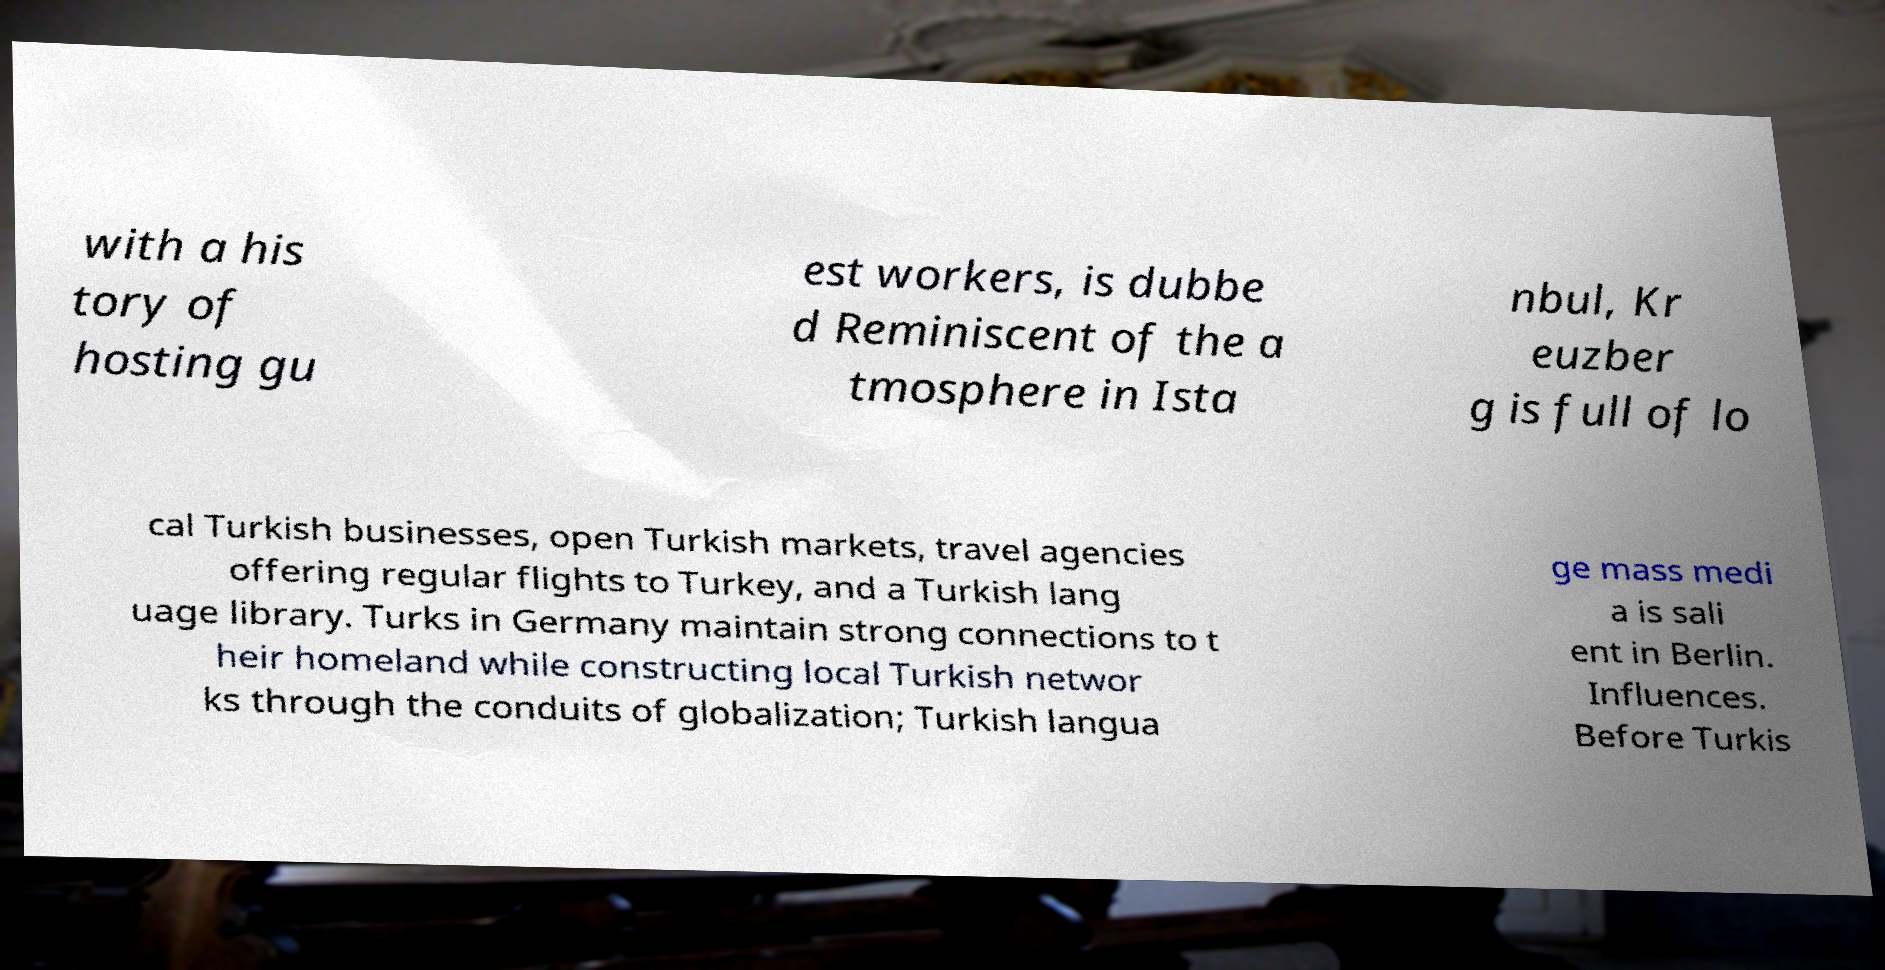What messages or text are displayed in this image? I need them in a readable, typed format. with a his tory of hosting gu est workers, is dubbe d Reminiscent of the a tmosphere in Ista nbul, Kr euzber g is full of lo cal Turkish businesses, open Turkish markets, travel agencies offering regular flights to Turkey, and a Turkish lang uage library. Turks in Germany maintain strong connections to t heir homeland while constructing local Turkish networ ks through the conduits of globalization; Turkish langua ge mass medi a is sali ent in Berlin. Influences. Before Turkis 